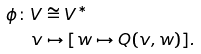<formula> <loc_0><loc_0><loc_500><loc_500>\phi \colon V & \cong V ^ { * } \\ v & \mapsto [ w \mapsto Q ( v , w ) ] .</formula> 